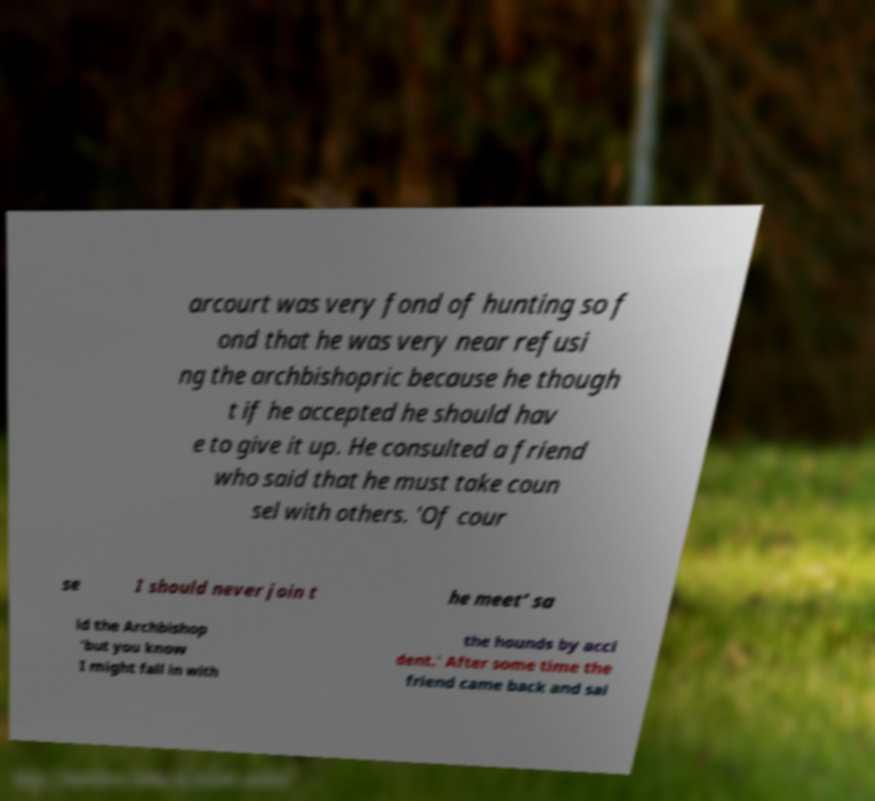I need the written content from this picture converted into text. Can you do that? arcourt was very fond of hunting so f ond that he was very near refusi ng the archbishopric because he though t if he accepted he should hav e to give it up. He consulted a friend who said that he must take coun sel with others. 'Of cour se I should never join t he meet’ sa id the Archbishop 'but you know I might fall in with the hounds by acci dent.' After some time the friend came back and sai 